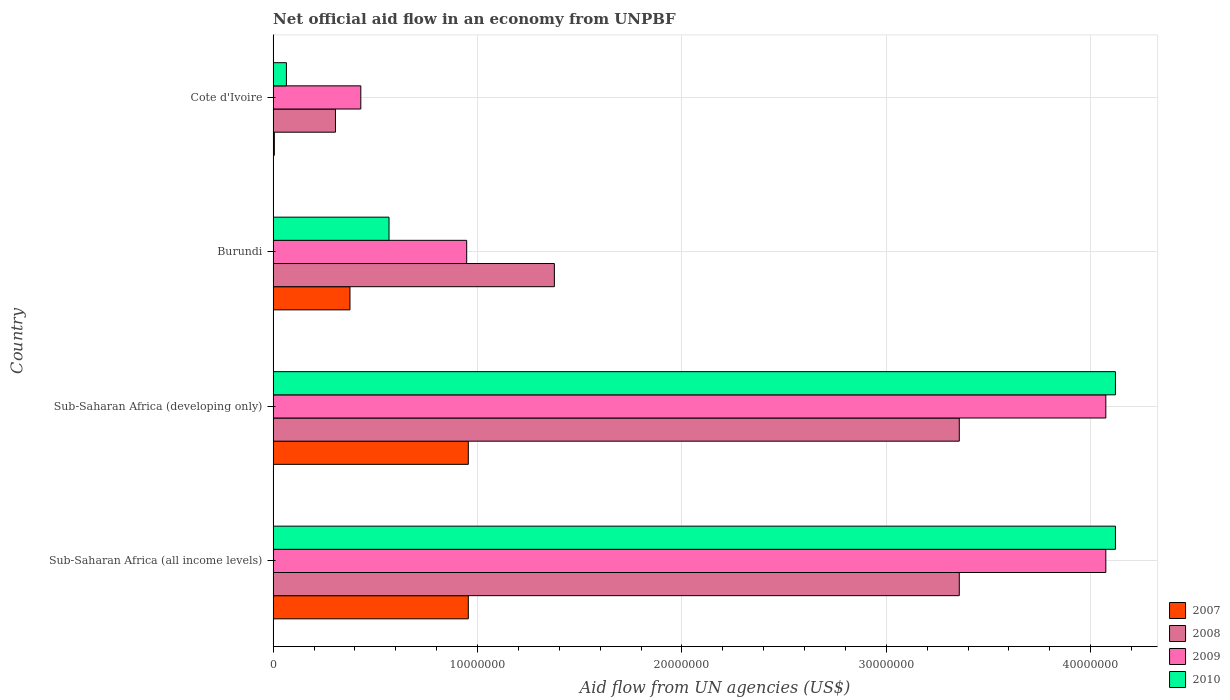How many different coloured bars are there?
Offer a terse response. 4. Are the number of bars per tick equal to the number of legend labels?
Give a very brief answer. Yes. How many bars are there on the 2nd tick from the bottom?
Provide a succinct answer. 4. What is the label of the 3rd group of bars from the top?
Offer a very short reply. Sub-Saharan Africa (developing only). In how many cases, is the number of bars for a given country not equal to the number of legend labels?
Provide a succinct answer. 0. What is the net official aid flow in 2008 in Sub-Saharan Africa (all income levels)?
Offer a very short reply. 3.36e+07. Across all countries, what is the maximum net official aid flow in 2009?
Keep it short and to the point. 4.07e+07. Across all countries, what is the minimum net official aid flow in 2008?
Give a very brief answer. 3.05e+06. In which country was the net official aid flow in 2007 maximum?
Your answer should be very brief. Sub-Saharan Africa (all income levels). In which country was the net official aid flow in 2008 minimum?
Keep it short and to the point. Cote d'Ivoire. What is the total net official aid flow in 2010 in the graph?
Offer a terse response. 8.87e+07. What is the difference between the net official aid flow in 2009 in Cote d'Ivoire and that in Sub-Saharan Africa (all income levels)?
Provide a succinct answer. -3.64e+07. What is the difference between the net official aid flow in 2008 in Sub-Saharan Africa (all income levels) and the net official aid flow in 2007 in Cote d'Ivoire?
Your answer should be very brief. 3.35e+07. What is the average net official aid flow in 2008 per country?
Make the answer very short. 2.10e+07. What is the difference between the net official aid flow in 2008 and net official aid flow in 2007 in Cote d'Ivoire?
Offer a terse response. 2.99e+06. In how many countries, is the net official aid flow in 2009 greater than 20000000 US$?
Your answer should be very brief. 2. What is the ratio of the net official aid flow in 2007 in Burundi to that in Sub-Saharan Africa (developing only)?
Offer a terse response. 0.39. Is the net official aid flow in 2008 in Cote d'Ivoire less than that in Sub-Saharan Africa (developing only)?
Your response must be concise. Yes. What is the difference between the highest and the second highest net official aid flow in 2007?
Make the answer very short. 0. What is the difference between the highest and the lowest net official aid flow in 2008?
Keep it short and to the point. 3.05e+07. In how many countries, is the net official aid flow in 2010 greater than the average net official aid flow in 2010 taken over all countries?
Keep it short and to the point. 2. Is it the case that in every country, the sum of the net official aid flow in 2009 and net official aid flow in 2007 is greater than the sum of net official aid flow in 2010 and net official aid flow in 2008?
Provide a succinct answer. No. What does the 3rd bar from the bottom in Sub-Saharan Africa (developing only) represents?
Your response must be concise. 2009. Is it the case that in every country, the sum of the net official aid flow in 2008 and net official aid flow in 2007 is greater than the net official aid flow in 2010?
Provide a short and direct response. Yes. How many bars are there?
Your answer should be very brief. 16. How many countries are there in the graph?
Make the answer very short. 4. What is the difference between two consecutive major ticks on the X-axis?
Provide a succinct answer. 1.00e+07. Does the graph contain any zero values?
Give a very brief answer. No. How many legend labels are there?
Offer a very short reply. 4. What is the title of the graph?
Make the answer very short. Net official aid flow in an economy from UNPBF. Does "2003" appear as one of the legend labels in the graph?
Offer a very short reply. No. What is the label or title of the X-axis?
Offer a very short reply. Aid flow from UN agencies (US$). What is the label or title of the Y-axis?
Give a very brief answer. Country. What is the Aid flow from UN agencies (US$) in 2007 in Sub-Saharan Africa (all income levels)?
Offer a terse response. 9.55e+06. What is the Aid flow from UN agencies (US$) in 2008 in Sub-Saharan Africa (all income levels)?
Offer a very short reply. 3.36e+07. What is the Aid flow from UN agencies (US$) in 2009 in Sub-Saharan Africa (all income levels)?
Offer a terse response. 4.07e+07. What is the Aid flow from UN agencies (US$) of 2010 in Sub-Saharan Africa (all income levels)?
Make the answer very short. 4.12e+07. What is the Aid flow from UN agencies (US$) of 2007 in Sub-Saharan Africa (developing only)?
Your answer should be compact. 9.55e+06. What is the Aid flow from UN agencies (US$) in 2008 in Sub-Saharan Africa (developing only)?
Provide a short and direct response. 3.36e+07. What is the Aid flow from UN agencies (US$) in 2009 in Sub-Saharan Africa (developing only)?
Provide a short and direct response. 4.07e+07. What is the Aid flow from UN agencies (US$) of 2010 in Sub-Saharan Africa (developing only)?
Provide a short and direct response. 4.12e+07. What is the Aid flow from UN agencies (US$) of 2007 in Burundi?
Provide a succinct answer. 3.76e+06. What is the Aid flow from UN agencies (US$) in 2008 in Burundi?
Give a very brief answer. 1.38e+07. What is the Aid flow from UN agencies (US$) of 2009 in Burundi?
Provide a succinct answer. 9.47e+06. What is the Aid flow from UN agencies (US$) in 2010 in Burundi?
Your response must be concise. 5.67e+06. What is the Aid flow from UN agencies (US$) of 2007 in Cote d'Ivoire?
Keep it short and to the point. 6.00e+04. What is the Aid flow from UN agencies (US$) of 2008 in Cote d'Ivoire?
Provide a short and direct response. 3.05e+06. What is the Aid flow from UN agencies (US$) of 2009 in Cote d'Ivoire?
Keep it short and to the point. 4.29e+06. What is the Aid flow from UN agencies (US$) of 2010 in Cote d'Ivoire?
Ensure brevity in your answer.  6.50e+05. Across all countries, what is the maximum Aid flow from UN agencies (US$) of 2007?
Offer a very short reply. 9.55e+06. Across all countries, what is the maximum Aid flow from UN agencies (US$) of 2008?
Your response must be concise. 3.36e+07. Across all countries, what is the maximum Aid flow from UN agencies (US$) in 2009?
Make the answer very short. 4.07e+07. Across all countries, what is the maximum Aid flow from UN agencies (US$) in 2010?
Your answer should be very brief. 4.12e+07. Across all countries, what is the minimum Aid flow from UN agencies (US$) in 2007?
Your answer should be compact. 6.00e+04. Across all countries, what is the minimum Aid flow from UN agencies (US$) in 2008?
Provide a succinct answer. 3.05e+06. Across all countries, what is the minimum Aid flow from UN agencies (US$) in 2009?
Give a very brief answer. 4.29e+06. Across all countries, what is the minimum Aid flow from UN agencies (US$) of 2010?
Provide a short and direct response. 6.50e+05. What is the total Aid flow from UN agencies (US$) of 2007 in the graph?
Make the answer very short. 2.29e+07. What is the total Aid flow from UN agencies (US$) of 2008 in the graph?
Your answer should be compact. 8.40e+07. What is the total Aid flow from UN agencies (US$) in 2009 in the graph?
Keep it short and to the point. 9.52e+07. What is the total Aid flow from UN agencies (US$) of 2010 in the graph?
Keep it short and to the point. 8.87e+07. What is the difference between the Aid flow from UN agencies (US$) in 2007 in Sub-Saharan Africa (all income levels) and that in Sub-Saharan Africa (developing only)?
Offer a very short reply. 0. What is the difference between the Aid flow from UN agencies (US$) of 2008 in Sub-Saharan Africa (all income levels) and that in Sub-Saharan Africa (developing only)?
Provide a short and direct response. 0. What is the difference between the Aid flow from UN agencies (US$) in 2009 in Sub-Saharan Africa (all income levels) and that in Sub-Saharan Africa (developing only)?
Make the answer very short. 0. What is the difference between the Aid flow from UN agencies (US$) in 2007 in Sub-Saharan Africa (all income levels) and that in Burundi?
Offer a very short reply. 5.79e+06. What is the difference between the Aid flow from UN agencies (US$) of 2008 in Sub-Saharan Africa (all income levels) and that in Burundi?
Ensure brevity in your answer.  1.98e+07. What is the difference between the Aid flow from UN agencies (US$) in 2009 in Sub-Saharan Africa (all income levels) and that in Burundi?
Ensure brevity in your answer.  3.13e+07. What is the difference between the Aid flow from UN agencies (US$) in 2010 in Sub-Saharan Africa (all income levels) and that in Burundi?
Offer a terse response. 3.55e+07. What is the difference between the Aid flow from UN agencies (US$) in 2007 in Sub-Saharan Africa (all income levels) and that in Cote d'Ivoire?
Provide a succinct answer. 9.49e+06. What is the difference between the Aid flow from UN agencies (US$) of 2008 in Sub-Saharan Africa (all income levels) and that in Cote d'Ivoire?
Provide a short and direct response. 3.05e+07. What is the difference between the Aid flow from UN agencies (US$) of 2009 in Sub-Saharan Africa (all income levels) and that in Cote d'Ivoire?
Provide a succinct answer. 3.64e+07. What is the difference between the Aid flow from UN agencies (US$) in 2010 in Sub-Saharan Africa (all income levels) and that in Cote d'Ivoire?
Your answer should be compact. 4.06e+07. What is the difference between the Aid flow from UN agencies (US$) of 2007 in Sub-Saharan Africa (developing only) and that in Burundi?
Give a very brief answer. 5.79e+06. What is the difference between the Aid flow from UN agencies (US$) in 2008 in Sub-Saharan Africa (developing only) and that in Burundi?
Your answer should be very brief. 1.98e+07. What is the difference between the Aid flow from UN agencies (US$) of 2009 in Sub-Saharan Africa (developing only) and that in Burundi?
Keep it short and to the point. 3.13e+07. What is the difference between the Aid flow from UN agencies (US$) in 2010 in Sub-Saharan Africa (developing only) and that in Burundi?
Ensure brevity in your answer.  3.55e+07. What is the difference between the Aid flow from UN agencies (US$) in 2007 in Sub-Saharan Africa (developing only) and that in Cote d'Ivoire?
Keep it short and to the point. 9.49e+06. What is the difference between the Aid flow from UN agencies (US$) of 2008 in Sub-Saharan Africa (developing only) and that in Cote d'Ivoire?
Provide a succinct answer. 3.05e+07. What is the difference between the Aid flow from UN agencies (US$) in 2009 in Sub-Saharan Africa (developing only) and that in Cote d'Ivoire?
Ensure brevity in your answer.  3.64e+07. What is the difference between the Aid flow from UN agencies (US$) of 2010 in Sub-Saharan Africa (developing only) and that in Cote d'Ivoire?
Provide a short and direct response. 4.06e+07. What is the difference between the Aid flow from UN agencies (US$) of 2007 in Burundi and that in Cote d'Ivoire?
Your response must be concise. 3.70e+06. What is the difference between the Aid flow from UN agencies (US$) in 2008 in Burundi and that in Cote d'Ivoire?
Your response must be concise. 1.07e+07. What is the difference between the Aid flow from UN agencies (US$) in 2009 in Burundi and that in Cote d'Ivoire?
Give a very brief answer. 5.18e+06. What is the difference between the Aid flow from UN agencies (US$) of 2010 in Burundi and that in Cote d'Ivoire?
Ensure brevity in your answer.  5.02e+06. What is the difference between the Aid flow from UN agencies (US$) in 2007 in Sub-Saharan Africa (all income levels) and the Aid flow from UN agencies (US$) in 2008 in Sub-Saharan Africa (developing only)?
Give a very brief answer. -2.40e+07. What is the difference between the Aid flow from UN agencies (US$) in 2007 in Sub-Saharan Africa (all income levels) and the Aid flow from UN agencies (US$) in 2009 in Sub-Saharan Africa (developing only)?
Keep it short and to the point. -3.12e+07. What is the difference between the Aid flow from UN agencies (US$) of 2007 in Sub-Saharan Africa (all income levels) and the Aid flow from UN agencies (US$) of 2010 in Sub-Saharan Africa (developing only)?
Offer a terse response. -3.17e+07. What is the difference between the Aid flow from UN agencies (US$) in 2008 in Sub-Saharan Africa (all income levels) and the Aid flow from UN agencies (US$) in 2009 in Sub-Saharan Africa (developing only)?
Ensure brevity in your answer.  -7.17e+06. What is the difference between the Aid flow from UN agencies (US$) of 2008 in Sub-Saharan Africa (all income levels) and the Aid flow from UN agencies (US$) of 2010 in Sub-Saharan Africa (developing only)?
Your answer should be compact. -7.64e+06. What is the difference between the Aid flow from UN agencies (US$) of 2009 in Sub-Saharan Africa (all income levels) and the Aid flow from UN agencies (US$) of 2010 in Sub-Saharan Africa (developing only)?
Your answer should be very brief. -4.70e+05. What is the difference between the Aid flow from UN agencies (US$) in 2007 in Sub-Saharan Africa (all income levels) and the Aid flow from UN agencies (US$) in 2008 in Burundi?
Provide a succinct answer. -4.21e+06. What is the difference between the Aid flow from UN agencies (US$) in 2007 in Sub-Saharan Africa (all income levels) and the Aid flow from UN agencies (US$) in 2009 in Burundi?
Give a very brief answer. 8.00e+04. What is the difference between the Aid flow from UN agencies (US$) in 2007 in Sub-Saharan Africa (all income levels) and the Aid flow from UN agencies (US$) in 2010 in Burundi?
Provide a succinct answer. 3.88e+06. What is the difference between the Aid flow from UN agencies (US$) of 2008 in Sub-Saharan Africa (all income levels) and the Aid flow from UN agencies (US$) of 2009 in Burundi?
Provide a succinct answer. 2.41e+07. What is the difference between the Aid flow from UN agencies (US$) of 2008 in Sub-Saharan Africa (all income levels) and the Aid flow from UN agencies (US$) of 2010 in Burundi?
Make the answer very short. 2.79e+07. What is the difference between the Aid flow from UN agencies (US$) of 2009 in Sub-Saharan Africa (all income levels) and the Aid flow from UN agencies (US$) of 2010 in Burundi?
Provide a short and direct response. 3.51e+07. What is the difference between the Aid flow from UN agencies (US$) of 2007 in Sub-Saharan Africa (all income levels) and the Aid flow from UN agencies (US$) of 2008 in Cote d'Ivoire?
Your answer should be compact. 6.50e+06. What is the difference between the Aid flow from UN agencies (US$) of 2007 in Sub-Saharan Africa (all income levels) and the Aid flow from UN agencies (US$) of 2009 in Cote d'Ivoire?
Make the answer very short. 5.26e+06. What is the difference between the Aid flow from UN agencies (US$) of 2007 in Sub-Saharan Africa (all income levels) and the Aid flow from UN agencies (US$) of 2010 in Cote d'Ivoire?
Keep it short and to the point. 8.90e+06. What is the difference between the Aid flow from UN agencies (US$) of 2008 in Sub-Saharan Africa (all income levels) and the Aid flow from UN agencies (US$) of 2009 in Cote d'Ivoire?
Your answer should be very brief. 2.93e+07. What is the difference between the Aid flow from UN agencies (US$) in 2008 in Sub-Saharan Africa (all income levels) and the Aid flow from UN agencies (US$) in 2010 in Cote d'Ivoire?
Give a very brief answer. 3.29e+07. What is the difference between the Aid flow from UN agencies (US$) of 2009 in Sub-Saharan Africa (all income levels) and the Aid flow from UN agencies (US$) of 2010 in Cote d'Ivoire?
Your answer should be very brief. 4.01e+07. What is the difference between the Aid flow from UN agencies (US$) of 2007 in Sub-Saharan Africa (developing only) and the Aid flow from UN agencies (US$) of 2008 in Burundi?
Your response must be concise. -4.21e+06. What is the difference between the Aid flow from UN agencies (US$) of 2007 in Sub-Saharan Africa (developing only) and the Aid flow from UN agencies (US$) of 2010 in Burundi?
Provide a short and direct response. 3.88e+06. What is the difference between the Aid flow from UN agencies (US$) of 2008 in Sub-Saharan Africa (developing only) and the Aid flow from UN agencies (US$) of 2009 in Burundi?
Offer a very short reply. 2.41e+07. What is the difference between the Aid flow from UN agencies (US$) in 2008 in Sub-Saharan Africa (developing only) and the Aid flow from UN agencies (US$) in 2010 in Burundi?
Your response must be concise. 2.79e+07. What is the difference between the Aid flow from UN agencies (US$) of 2009 in Sub-Saharan Africa (developing only) and the Aid flow from UN agencies (US$) of 2010 in Burundi?
Make the answer very short. 3.51e+07. What is the difference between the Aid flow from UN agencies (US$) in 2007 in Sub-Saharan Africa (developing only) and the Aid flow from UN agencies (US$) in 2008 in Cote d'Ivoire?
Offer a terse response. 6.50e+06. What is the difference between the Aid flow from UN agencies (US$) in 2007 in Sub-Saharan Africa (developing only) and the Aid flow from UN agencies (US$) in 2009 in Cote d'Ivoire?
Your answer should be very brief. 5.26e+06. What is the difference between the Aid flow from UN agencies (US$) in 2007 in Sub-Saharan Africa (developing only) and the Aid flow from UN agencies (US$) in 2010 in Cote d'Ivoire?
Offer a very short reply. 8.90e+06. What is the difference between the Aid flow from UN agencies (US$) of 2008 in Sub-Saharan Africa (developing only) and the Aid flow from UN agencies (US$) of 2009 in Cote d'Ivoire?
Offer a very short reply. 2.93e+07. What is the difference between the Aid flow from UN agencies (US$) of 2008 in Sub-Saharan Africa (developing only) and the Aid flow from UN agencies (US$) of 2010 in Cote d'Ivoire?
Your answer should be compact. 3.29e+07. What is the difference between the Aid flow from UN agencies (US$) in 2009 in Sub-Saharan Africa (developing only) and the Aid flow from UN agencies (US$) in 2010 in Cote d'Ivoire?
Offer a very short reply. 4.01e+07. What is the difference between the Aid flow from UN agencies (US$) of 2007 in Burundi and the Aid flow from UN agencies (US$) of 2008 in Cote d'Ivoire?
Provide a short and direct response. 7.10e+05. What is the difference between the Aid flow from UN agencies (US$) of 2007 in Burundi and the Aid flow from UN agencies (US$) of 2009 in Cote d'Ivoire?
Ensure brevity in your answer.  -5.30e+05. What is the difference between the Aid flow from UN agencies (US$) in 2007 in Burundi and the Aid flow from UN agencies (US$) in 2010 in Cote d'Ivoire?
Keep it short and to the point. 3.11e+06. What is the difference between the Aid flow from UN agencies (US$) in 2008 in Burundi and the Aid flow from UN agencies (US$) in 2009 in Cote d'Ivoire?
Offer a very short reply. 9.47e+06. What is the difference between the Aid flow from UN agencies (US$) of 2008 in Burundi and the Aid flow from UN agencies (US$) of 2010 in Cote d'Ivoire?
Your response must be concise. 1.31e+07. What is the difference between the Aid flow from UN agencies (US$) in 2009 in Burundi and the Aid flow from UN agencies (US$) in 2010 in Cote d'Ivoire?
Give a very brief answer. 8.82e+06. What is the average Aid flow from UN agencies (US$) of 2007 per country?
Your answer should be compact. 5.73e+06. What is the average Aid flow from UN agencies (US$) in 2008 per country?
Provide a succinct answer. 2.10e+07. What is the average Aid flow from UN agencies (US$) of 2009 per country?
Your answer should be compact. 2.38e+07. What is the average Aid flow from UN agencies (US$) of 2010 per country?
Ensure brevity in your answer.  2.22e+07. What is the difference between the Aid flow from UN agencies (US$) in 2007 and Aid flow from UN agencies (US$) in 2008 in Sub-Saharan Africa (all income levels)?
Make the answer very short. -2.40e+07. What is the difference between the Aid flow from UN agencies (US$) in 2007 and Aid flow from UN agencies (US$) in 2009 in Sub-Saharan Africa (all income levels)?
Offer a terse response. -3.12e+07. What is the difference between the Aid flow from UN agencies (US$) in 2007 and Aid flow from UN agencies (US$) in 2010 in Sub-Saharan Africa (all income levels)?
Give a very brief answer. -3.17e+07. What is the difference between the Aid flow from UN agencies (US$) of 2008 and Aid flow from UN agencies (US$) of 2009 in Sub-Saharan Africa (all income levels)?
Keep it short and to the point. -7.17e+06. What is the difference between the Aid flow from UN agencies (US$) of 2008 and Aid flow from UN agencies (US$) of 2010 in Sub-Saharan Africa (all income levels)?
Offer a very short reply. -7.64e+06. What is the difference between the Aid flow from UN agencies (US$) in 2009 and Aid flow from UN agencies (US$) in 2010 in Sub-Saharan Africa (all income levels)?
Provide a short and direct response. -4.70e+05. What is the difference between the Aid flow from UN agencies (US$) in 2007 and Aid flow from UN agencies (US$) in 2008 in Sub-Saharan Africa (developing only)?
Keep it short and to the point. -2.40e+07. What is the difference between the Aid flow from UN agencies (US$) in 2007 and Aid flow from UN agencies (US$) in 2009 in Sub-Saharan Africa (developing only)?
Offer a terse response. -3.12e+07. What is the difference between the Aid flow from UN agencies (US$) of 2007 and Aid flow from UN agencies (US$) of 2010 in Sub-Saharan Africa (developing only)?
Provide a short and direct response. -3.17e+07. What is the difference between the Aid flow from UN agencies (US$) of 2008 and Aid flow from UN agencies (US$) of 2009 in Sub-Saharan Africa (developing only)?
Your response must be concise. -7.17e+06. What is the difference between the Aid flow from UN agencies (US$) of 2008 and Aid flow from UN agencies (US$) of 2010 in Sub-Saharan Africa (developing only)?
Give a very brief answer. -7.64e+06. What is the difference between the Aid flow from UN agencies (US$) of 2009 and Aid flow from UN agencies (US$) of 2010 in Sub-Saharan Africa (developing only)?
Provide a succinct answer. -4.70e+05. What is the difference between the Aid flow from UN agencies (US$) of 2007 and Aid flow from UN agencies (US$) of 2008 in Burundi?
Offer a terse response. -1.00e+07. What is the difference between the Aid flow from UN agencies (US$) in 2007 and Aid flow from UN agencies (US$) in 2009 in Burundi?
Your response must be concise. -5.71e+06. What is the difference between the Aid flow from UN agencies (US$) in 2007 and Aid flow from UN agencies (US$) in 2010 in Burundi?
Offer a very short reply. -1.91e+06. What is the difference between the Aid flow from UN agencies (US$) in 2008 and Aid flow from UN agencies (US$) in 2009 in Burundi?
Provide a short and direct response. 4.29e+06. What is the difference between the Aid flow from UN agencies (US$) of 2008 and Aid flow from UN agencies (US$) of 2010 in Burundi?
Your response must be concise. 8.09e+06. What is the difference between the Aid flow from UN agencies (US$) in 2009 and Aid flow from UN agencies (US$) in 2010 in Burundi?
Give a very brief answer. 3.80e+06. What is the difference between the Aid flow from UN agencies (US$) of 2007 and Aid flow from UN agencies (US$) of 2008 in Cote d'Ivoire?
Your response must be concise. -2.99e+06. What is the difference between the Aid flow from UN agencies (US$) in 2007 and Aid flow from UN agencies (US$) in 2009 in Cote d'Ivoire?
Keep it short and to the point. -4.23e+06. What is the difference between the Aid flow from UN agencies (US$) in 2007 and Aid flow from UN agencies (US$) in 2010 in Cote d'Ivoire?
Give a very brief answer. -5.90e+05. What is the difference between the Aid flow from UN agencies (US$) of 2008 and Aid flow from UN agencies (US$) of 2009 in Cote d'Ivoire?
Your response must be concise. -1.24e+06. What is the difference between the Aid flow from UN agencies (US$) of 2008 and Aid flow from UN agencies (US$) of 2010 in Cote d'Ivoire?
Keep it short and to the point. 2.40e+06. What is the difference between the Aid flow from UN agencies (US$) in 2009 and Aid flow from UN agencies (US$) in 2010 in Cote d'Ivoire?
Your response must be concise. 3.64e+06. What is the ratio of the Aid flow from UN agencies (US$) of 2010 in Sub-Saharan Africa (all income levels) to that in Sub-Saharan Africa (developing only)?
Ensure brevity in your answer.  1. What is the ratio of the Aid flow from UN agencies (US$) of 2007 in Sub-Saharan Africa (all income levels) to that in Burundi?
Keep it short and to the point. 2.54. What is the ratio of the Aid flow from UN agencies (US$) of 2008 in Sub-Saharan Africa (all income levels) to that in Burundi?
Keep it short and to the point. 2.44. What is the ratio of the Aid flow from UN agencies (US$) of 2009 in Sub-Saharan Africa (all income levels) to that in Burundi?
Make the answer very short. 4.3. What is the ratio of the Aid flow from UN agencies (US$) in 2010 in Sub-Saharan Africa (all income levels) to that in Burundi?
Make the answer very short. 7.27. What is the ratio of the Aid flow from UN agencies (US$) in 2007 in Sub-Saharan Africa (all income levels) to that in Cote d'Ivoire?
Keep it short and to the point. 159.17. What is the ratio of the Aid flow from UN agencies (US$) of 2008 in Sub-Saharan Africa (all income levels) to that in Cote d'Ivoire?
Ensure brevity in your answer.  11.01. What is the ratio of the Aid flow from UN agencies (US$) of 2009 in Sub-Saharan Africa (all income levels) to that in Cote d'Ivoire?
Keep it short and to the point. 9.5. What is the ratio of the Aid flow from UN agencies (US$) of 2010 in Sub-Saharan Africa (all income levels) to that in Cote d'Ivoire?
Your answer should be compact. 63.4. What is the ratio of the Aid flow from UN agencies (US$) of 2007 in Sub-Saharan Africa (developing only) to that in Burundi?
Make the answer very short. 2.54. What is the ratio of the Aid flow from UN agencies (US$) in 2008 in Sub-Saharan Africa (developing only) to that in Burundi?
Your response must be concise. 2.44. What is the ratio of the Aid flow from UN agencies (US$) of 2009 in Sub-Saharan Africa (developing only) to that in Burundi?
Provide a short and direct response. 4.3. What is the ratio of the Aid flow from UN agencies (US$) in 2010 in Sub-Saharan Africa (developing only) to that in Burundi?
Provide a succinct answer. 7.27. What is the ratio of the Aid flow from UN agencies (US$) of 2007 in Sub-Saharan Africa (developing only) to that in Cote d'Ivoire?
Make the answer very short. 159.17. What is the ratio of the Aid flow from UN agencies (US$) in 2008 in Sub-Saharan Africa (developing only) to that in Cote d'Ivoire?
Offer a terse response. 11.01. What is the ratio of the Aid flow from UN agencies (US$) of 2009 in Sub-Saharan Africa (developing only) to that in Cote d'Ivoire?
Ensure brevity in your answer.  9.5. What is the ratio of the Aid flow from UN agencies (US$) in 2010 in Sub-Saharan Africa (developing only) to that in Cote d'Ivoire?
Your answer should be very brief. 63.4. What is the ratio of the Aid flow from UN agencies (US$) in 2007 in Burundi to that in Cote d'Ivoire?
Make the answer very short. 62.67. What is the ratio of the Aid flow from UN agencies (US$) in 2008 in Burundi to that in Cote d'Ivoire?
Offer a very short reply. 4.51. What is the ratio of the Aid flow from UN agencies (US$) of 2009 in Burundi to that in Cote d'Ivoire?
Provide a succinct answer. 2.21. What is the ratio of the Aid flow from UN agencies (US$) in 2010 in Burundi to that in Cote d'Ivoire?
Offer a terse response. 8.72. What is the difference between the highest and the second highest Aid flow from UN agencies (US$) of 2010?
Your answer should be compact. 0. What is the difference between the highest and the lowest Aid flow from UN agencies (US$) of 2007?
Provide a short and direct response. 9.49e+06. What is the difference between the highest and the lowest Aid flow from UN agencies (US$) in 2008?
Offer a terse response. 3.05e+07. What is the difference between the highest and the lowest Aid flow from UN agencies (US$) in 2009?
Your answer should be very brief. 3.64e+07. What is the difference between the highest and the lowest Aid flow from UN agencies (US$) in 2010?
Make the answer very short. 4.06e+07. 